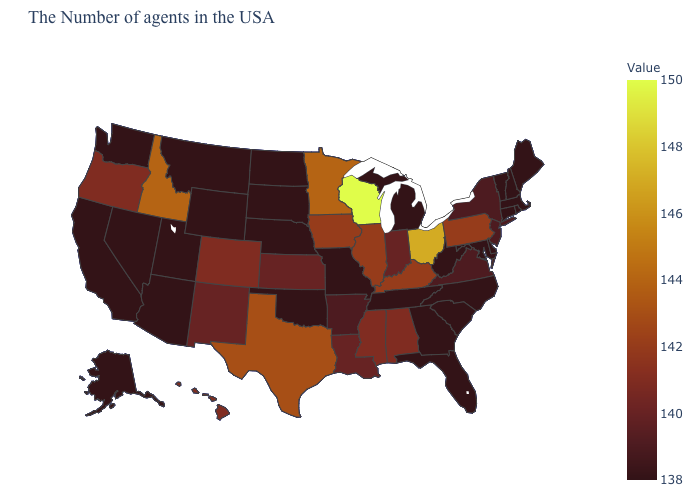Does Ohio have a lower value than Oklahoma?
Concise answer only. No. Does Kentucky have the highest value in the USA?
Quick response, please. No. Does the map have missing data?
Quick response, please. No. Among the states that border Alabama , does Mississippi have the lowest value?
Keep it brief. No. 